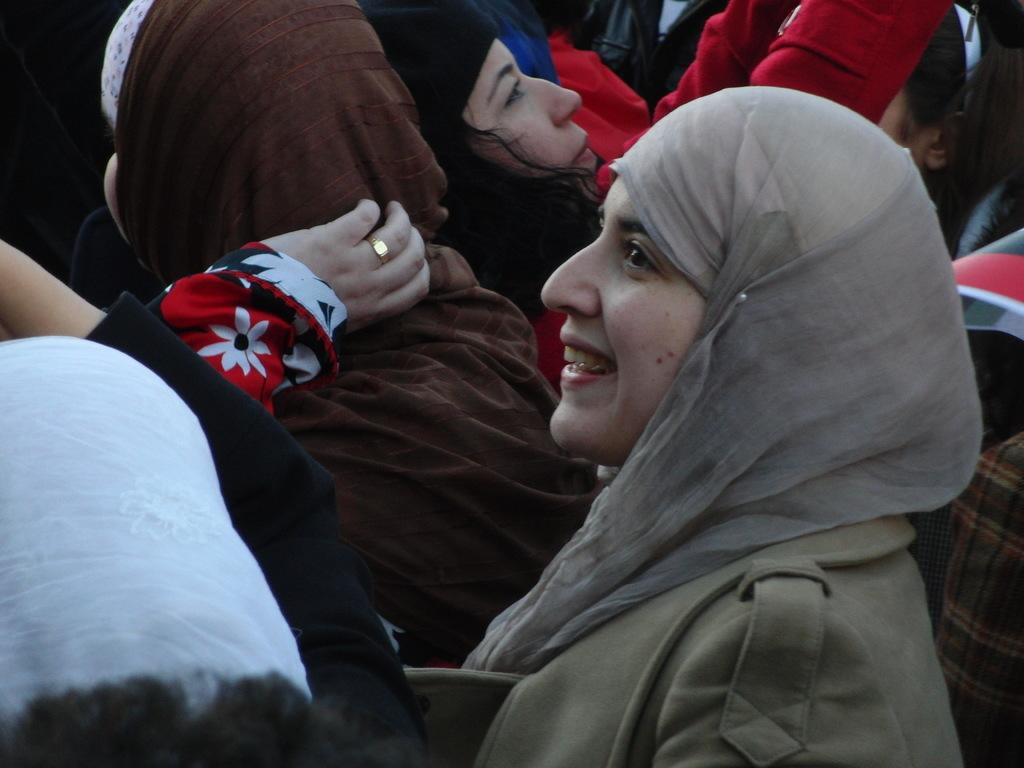What is the main subject of the image? The main subject of the image is a group of ladies. What are the ladies doing in the image? The ladies are standing in the image. What accessory is each lady wearing on their head? Each lady is wearing a scarf on their head. What color is the burn on the lady's hand in the image? There is no burn present on any lady's hand in the image. 